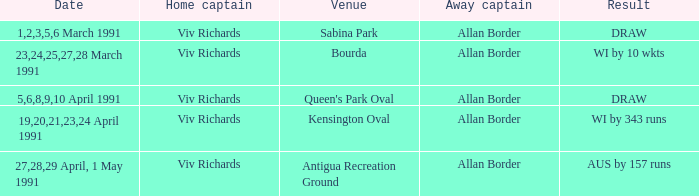What dates had matches at the venue Sabina Park? 1,2,3,5,6 March 1991. 